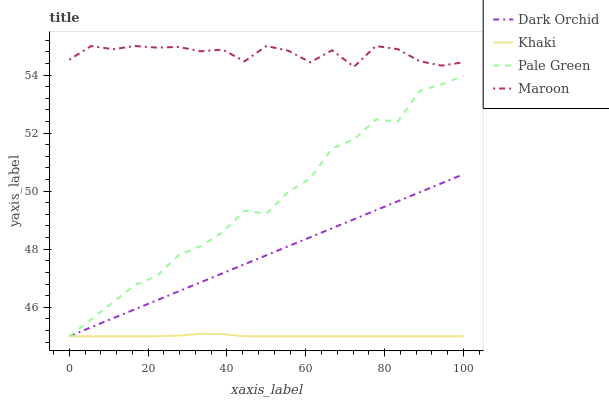Does Khaki have the minimum area under the curve?
Answer yes or no. Yes. Does Maroon have the maximum area under the curve?
Answer yes or no. Yes. Does Maroon have the minimum area under the curve?
Answer yes or no. No. Does Khaki have the maximum area under the curve?
Answer yes or no. No. Is Dark Orchid the smoothest?
Answer yes or no. Yes. Is Maroon the roughest?
Answer yes or no. Yes. Is Khaki the smoothest?
Answer yes or no. No. Is Khaki the roughest?
Answer yes or no. No. Does Pale Green have the lowest value?
Answer yes or no. Yes. Does Maroon have the lowest value?
Answer yes or no. No. Does Maroon have the highest value?
Answer yes or no. Yes. Does Khaki have the highest value?
Answer yes or no. No. Is Pale Green less than Maroon?
Answer yes or no. Yes. Is Maroon greater than Khaki?
Answer yes or no. Yes. Does Pale Green intersect Khaki?
Answer yes or no. Yes. Is Pale Green less than Khaki?
Answer yes or no. No. Is Pale Green greater than Khaki?
Answer yes or no. No. Does Pale Green intersect Maroon?
Answer yes or no. No. 